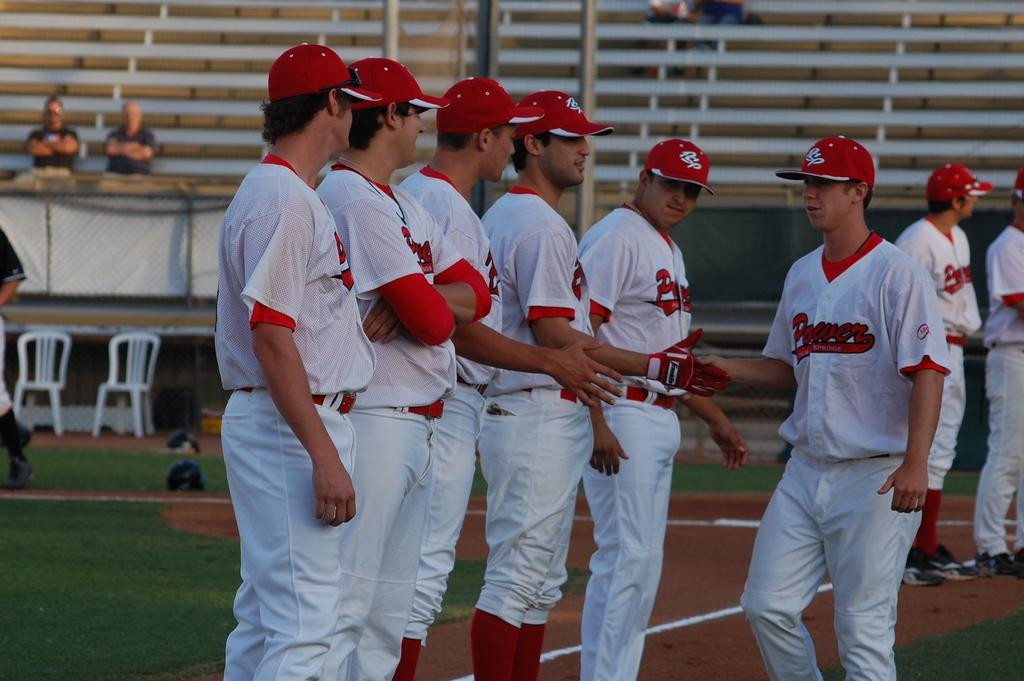Provide a one-sentence caption for the provided image. Members of the Power team are lines up as one teammate walks along and shakes their hands. 